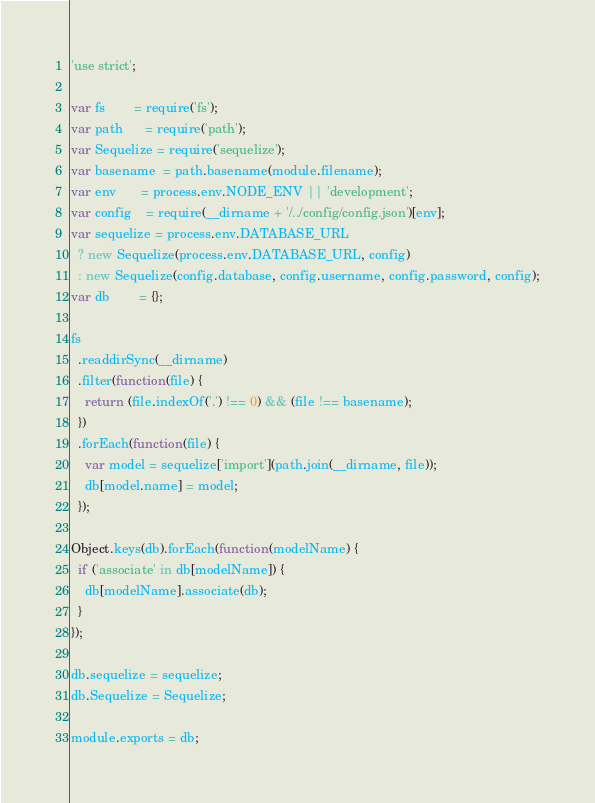<code> <loc_0><loc_0><loc_500><loc_500><_JavaScript_>'use strict';

var fs        = require('fs');
var path      = require('path');
var Sequelize = require('sequelize');
var basename  = path.basename(module.filename);
var env       = process.env.NODE_ENV || 'development';
var config    = require(__dirname + '/../config/config.json')[env];
var sequelize = process.env.DATABASE_URL
  ? new Sequelize(process.env.DATABASE_URL, config)
  : new Sequelize(config.database, config.username, config.password, config);
var db        = {};

fs
  .readdirSync(__dirname)
  .filter(function(file) {
    return (file.indexOf('.') !== 0) && (file !== basename);
  })
  .forEach(function(file) {
    var model = sequelize['import'](path.join(__dirname, file));
    db[model.name] = model;
  });

Object.keys(db).forEach(function(modelName) {
  if ('associate' in db[modelName]) {
    db[modelName].associate(db);
  }
});

db.sequelize = sequelize;
db.Sequelize = Sequelize;

module.exports = db;
</code> 